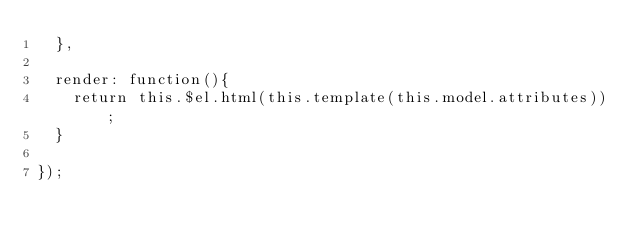<code> <loc_0><loc_0><loc_500><loc_500><_JavaScript_>  },

  render: function(){
    return this.$el.html(this.template(this.model.attributes));
  }

});
</code> 